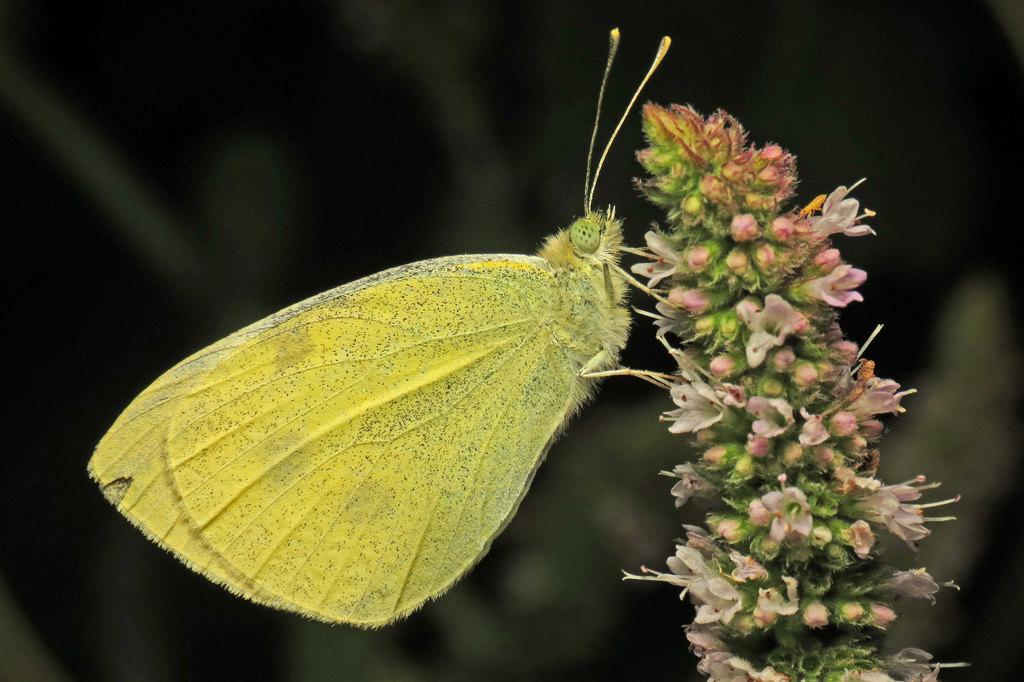What type of insect is in the image? There is a green color butterfly in the image. Where is the butterfly located? The butterfly is on a plant. What can be found on the plant besides the butterfly? There are flowers on the plant. Can you describe the background of the image? The background of the image is blurred. What is the mass of the lamp in the image? There is no lamp present in the image, so it is not possible to determine its mass. 